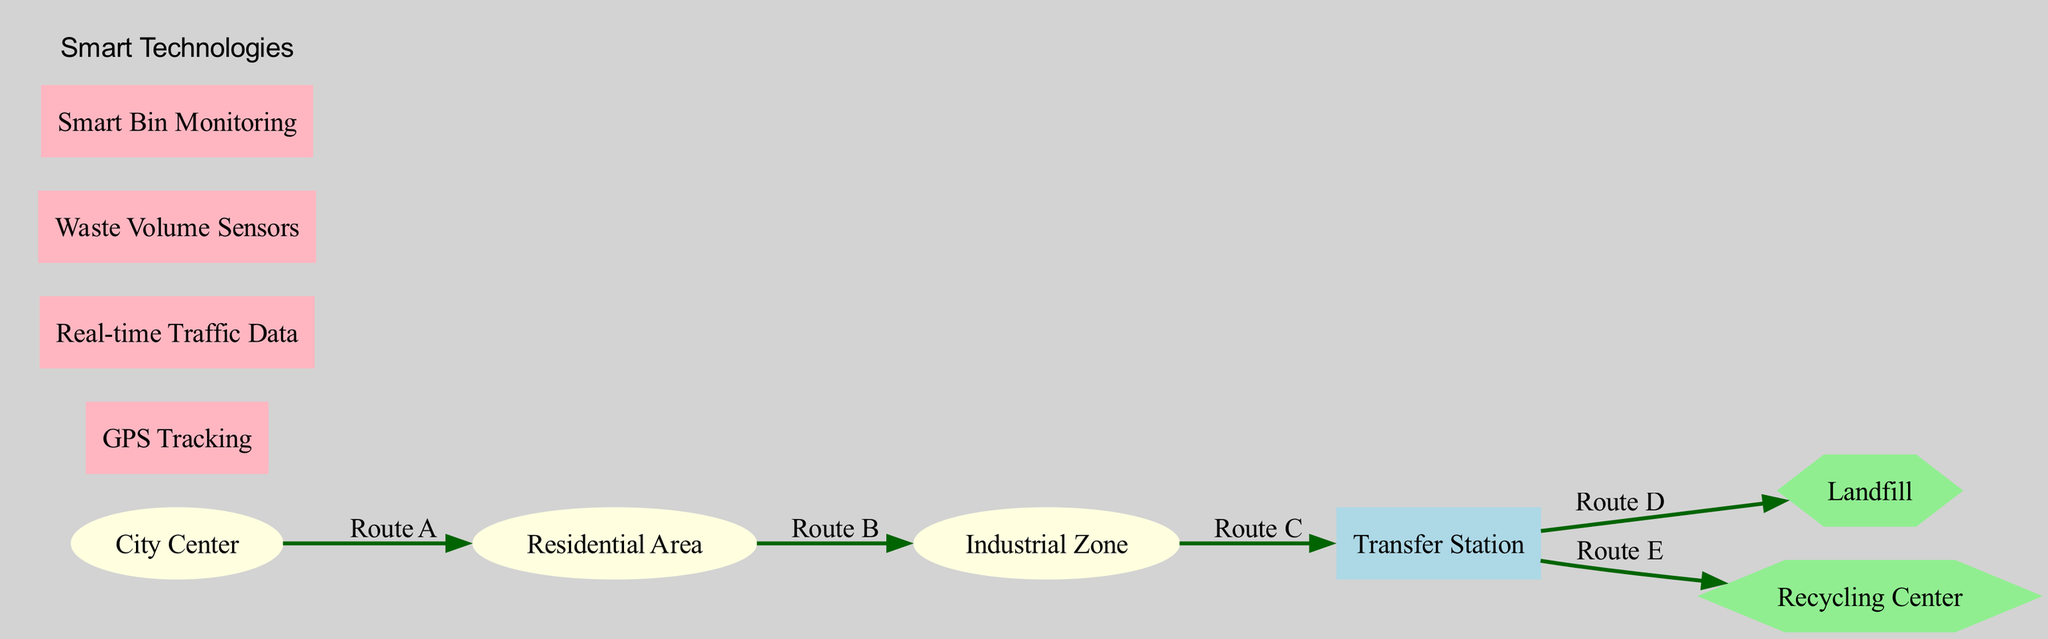What is the label of node 4? Node 4 is represented as the Transfer Station in the diagram. The label of node 4 is directly indicated on the diagram next to the node itself.
Answer: Transfer Station How many nodes are there in the diagram? The diagram contains a total of 6 nodes: City Center, Residential Area, Industrial Zone, Transfer Station, Landfill, and Recycling Center. This count comes from the nodes section in the data.
Answer: 6 What route connects the Industrial Zone to the Transfer Station? The route labeled as Route C connects the Industrial Zone (node 3) to the Transfer Station (node 4). This information is found by examining the edges and their corresponding labels in the diagram.
Answer: Route C Which two nodes are directly connected by Route D? Route D connects the Transfer Station (node 4) to the Landfill (node 5). This can be determined by looking at the edges data for the connection from node 4 to node 5 labeled as Route D.
Answer: Transfer Station and Landfill What is the shape of the nodes for the Landfill and Recycling Center? Both the Landfill (node 5) and Recycling Center (node 6) are represented as hexagons in the diagram, which is specified in the node addition process based on their IDs.
Answer: Hexagon How does one get from the City Center to the Recycling Center? To travel from the City Center (node 1) to the Recycling Center (node 6), you would first go to the Residential Area (node 2), then to the Industrial Zone (node 3), proceed to the Transfer Station (node 4), and finally move to the Recycling Center (node 6). This follows the routes A, B, C, and E in that sequence.
Answer: Route A, Route B, Route C, Route E What type of node is the Transfer Station? The Transfer Station (node 4) is represented as a rectangle in the diagram, which is indicated by its shape during the node creation in the code.
Answer: Rectangle Which technology is used for monitoring waste volume? The technology used for monitoring waste volume in this diagram is identified as Waste Volume Sensors in the attributes section. It is included to show how smart technologies apply to waste collection.
Answer: Waste Volume Sensors How many edges are there in total? There are 5 edges in total illustrated in the diagram that represent the routes for waste collection between various nodes. This is derived from the edges list in the data.
Answer: 5 